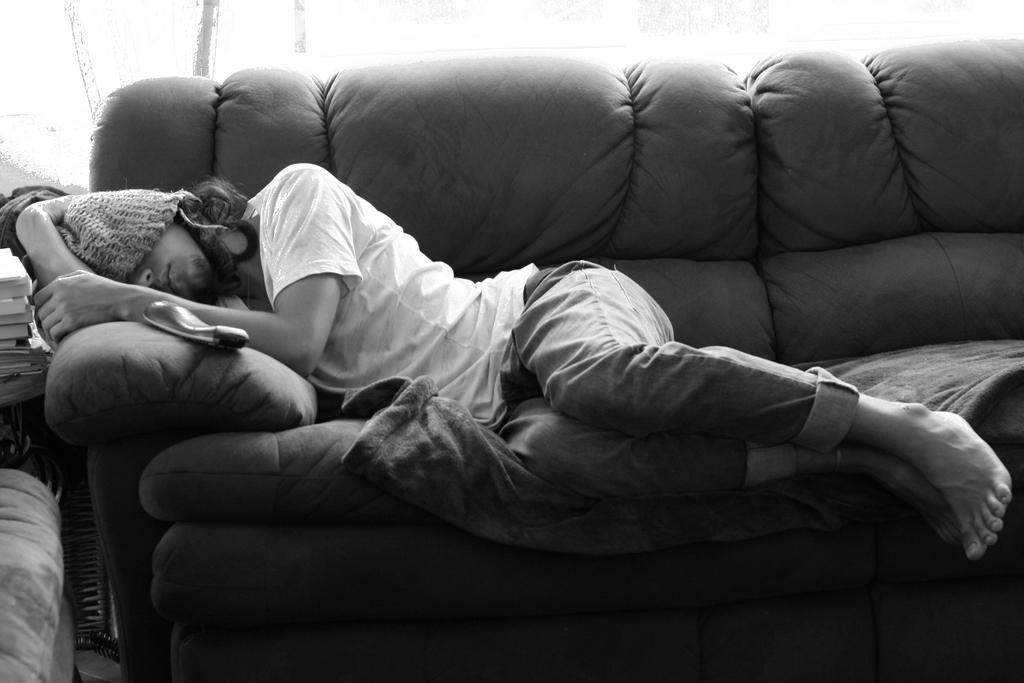Who is present in the image? There is a man in the image. What is the man doing in the image? The man is laying on a couch. What type of salt can be seen on the frame of the couch in the image? There is no salt or frame of the couch visible in the image; it only shows a man laying on a couch. 